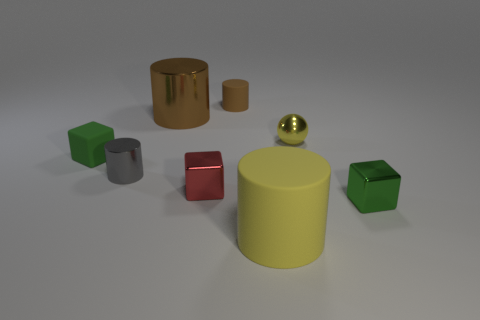Do the yellow matte thing and the tiny green rubber object have the same shape?
Make the answer very short. No. What size is the shiny object that is to the left of the big yellow rubber cylinder and behind the tiny matte block?
Provide a succinct answer. Large. There is another brown thing that is the same shape as the brown metal thing; what is it made of?
Offer a very short reply. Rubber. What is the material of the large cylinder that is behind the tiny green cube on the left side of the ball?
Make the answer very short. Metal. Does the tiny brown object have the same shape as the rubber object that is to the left of the small rubber cylinder?
Your answer should be very brief. No. How many metallic things are gray objects or large yellow cylinders?
Provide a short and direct response. 1. There is a small metallic object behind the green block behind the tiny green thing that is in front of the red thing; what color is it?
Offer a very short reply. Yellow. How many other objects are the same material as the tiny gray object?
Your answer should be compact. 4. There is a green object on the left side of the small yellow metallic ball; is its shape the same as the red shiny object?
Make the answer very short. Yes. How many small objects are either cyan metallic objects or brown things?
Your answer should be very brief. 1. 